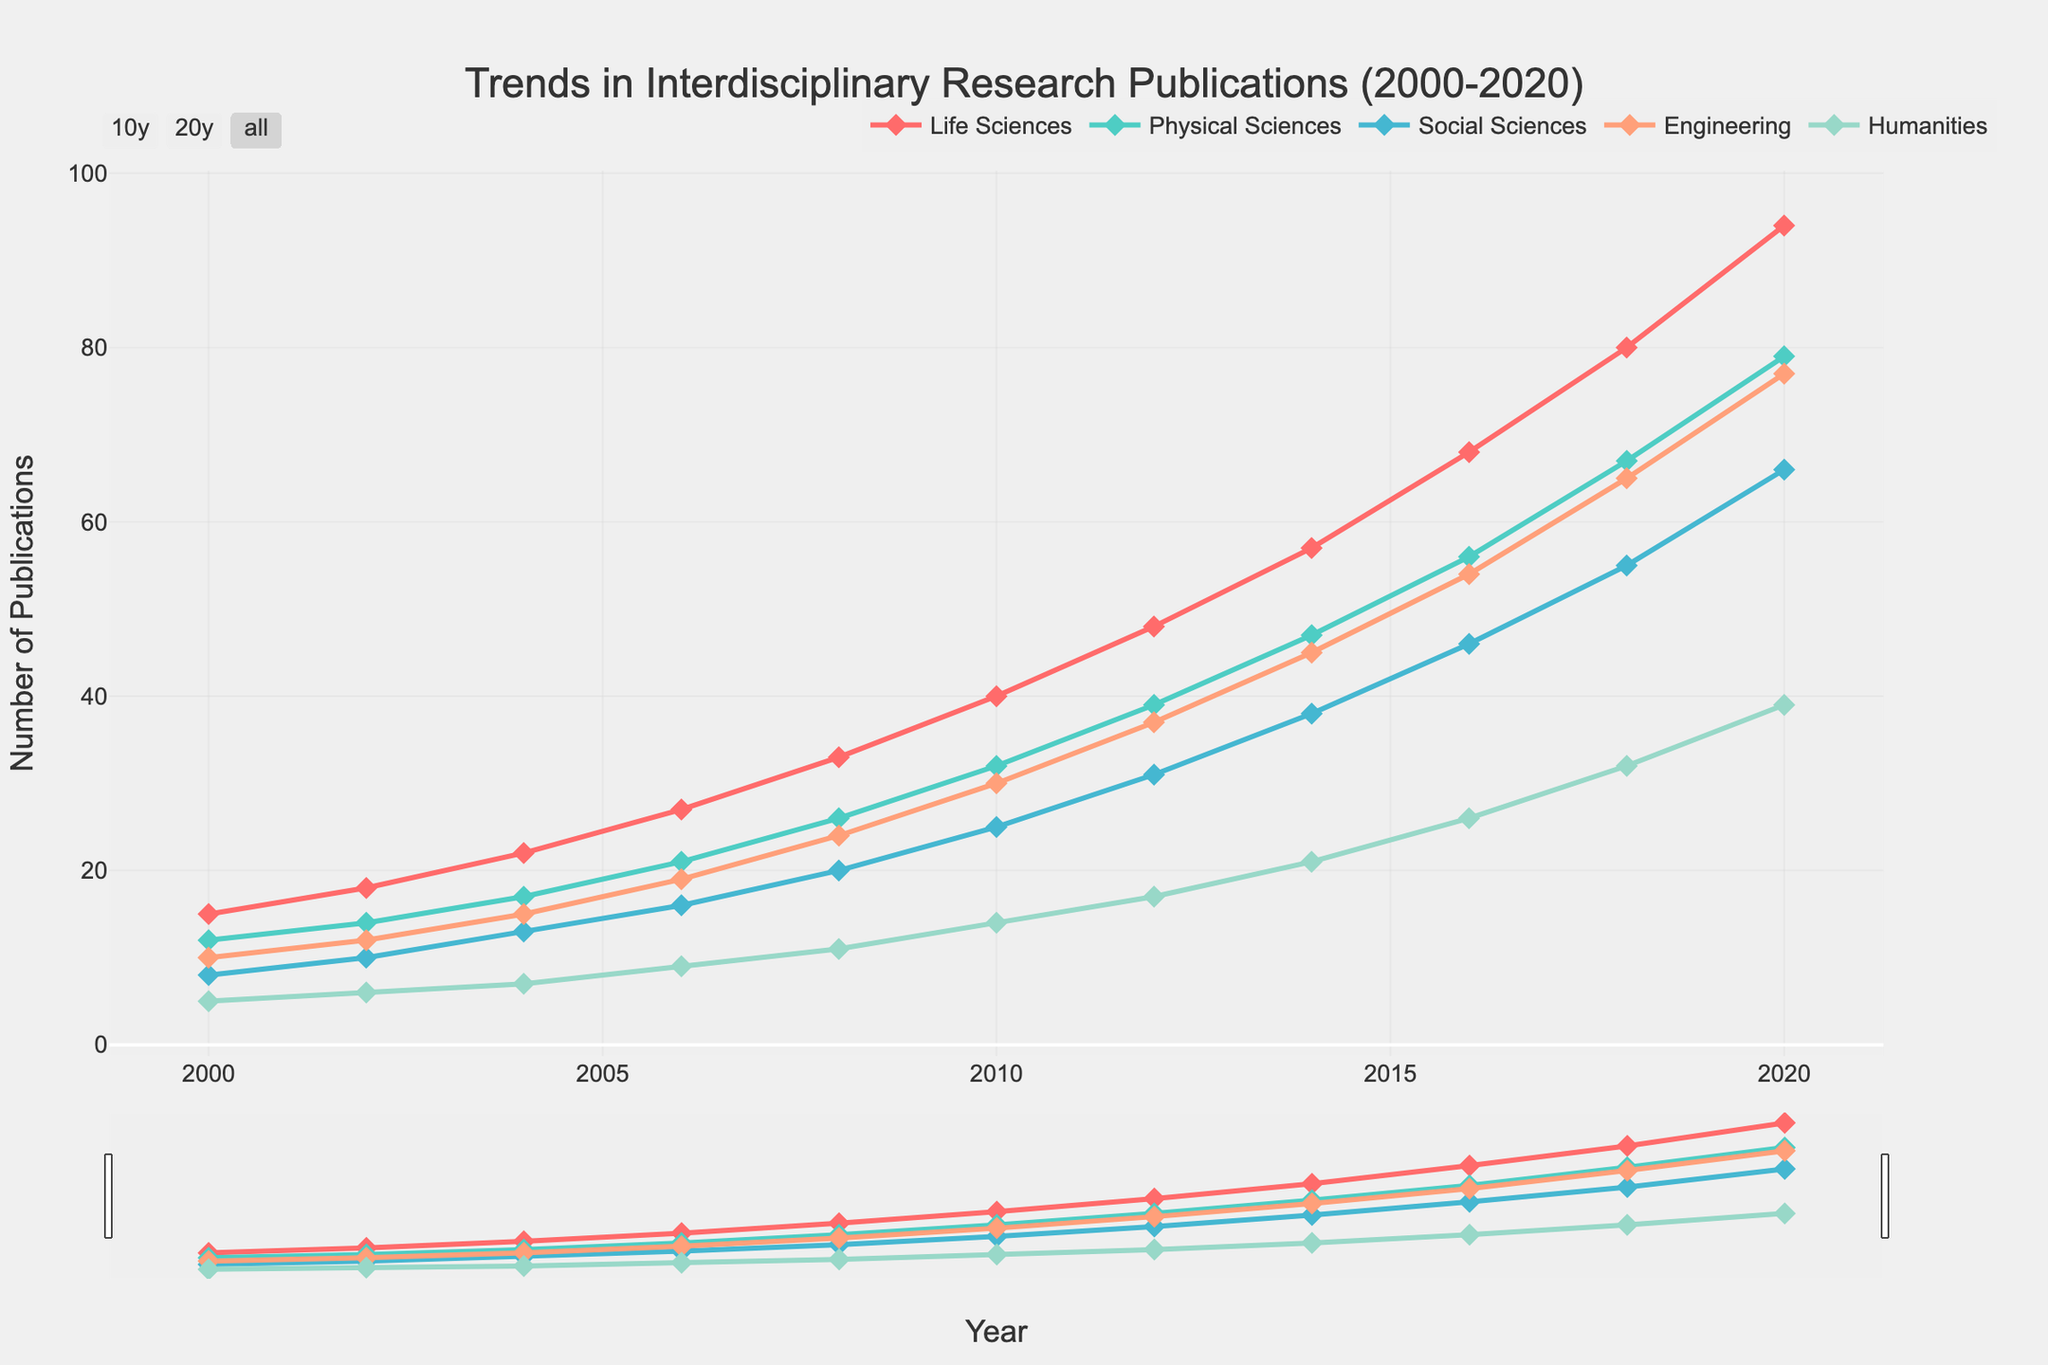Which academic field had the highest number of interdisciplinary research publications in 2020? To find the field with the highest number of publications in 2020, look at the data for that year across all fields. Life Sciences has 94, which is the highest among all fields.
Answer: Life Sciences Which two academic fields showed the greatest increase in interdisciplinary research publications from 2000 to 2020? Calculate the difference in publications between 2000 and 2020 for each field. Life Sciences increased by 79 (94-15), Physical Sciences by 67 (79-12), Social Sciences by 58 (66-8), Engineering by 67 (77-10), and Humanities by 34 (39-5). The two fields with the highest increases are Life Sciences and Physical Sciences (or Engineering, as both have the same increase).
Answer: Life Sciences and Physical Sciences (or Engineering) What is the trend in interdisciplinary research publications in the Humanities compared to Social Sciences from 2000 to 2020? Compare the lines for Humanities and Social Sciences over the years. Both lines show an upward trend, but Social Sciences have consistently higher publications than Humanities throughout the period. Both fields show significant growth, but Social Sciences grow at a slightly faster rate.
Answer: Both show upward trends, Social Sciences have faster growth By how many publications did Engineering exceed Humanities in 2018? Look at the publication numbers for Engineering and Humanities in 2018: Engineering has 65, and Humanities have 32. The difference is 65 - 32 = 33.
Answer: 33 What is the average number of interdisciplinary research publications for Physical Sciences from 2000 to 2020? Sum the publications for Physical Sciences over the years (12+14+17+21+26+32+39+47+56+67+79 = 410) and divide by the number of years (11). The average is 410 / 11 ≈ 37.27.
Answer: 37.27 Which year saw the highest annual increase in interdisciplinary research publications for Life Sciences? Compare the annual increase in publications for Life Sciences. The largest increase occurs between 2018 (80) and 2020 (94), with an increase of 14 publications.
Answer: 2018-2020 What is the ratio of interdisciplinary research publications in Life Sciences to Humanities in 2020? Look at the publication numbers for Life Sciences (94) and Humanities (39) in 2020. The ratio is 94:39.
Answer: 94:39 How did the publication trends for Engineering and Physical Sciences converge or diverge over the years? Compare the lines for Engineering and Physical Sciences from 2000 to 2020. Both fields show similar growth patterns and rates, maintaining a consistent gap and representing parallel trends over the years, particularly post-2010.
Answer: Converged slightly, maintaining consistent gap What is the combined total number of interdisciplinary research publications across all fields in 2020? Sum the publications for all fields in 2020: 94 (Life Sciences) + 79 (Physical Sciences) + 66 (Social Sciences) + 77 (Engineering) + 39 (Humanities) = 355.
Answer: 355 What is the percentage increase in interdisciplinary research publications in Social Sciences from 2000 to 2020? Calculate the percentage increase: [(66 - 8) / 8] * 100 = 725%.
Answer: 725% 